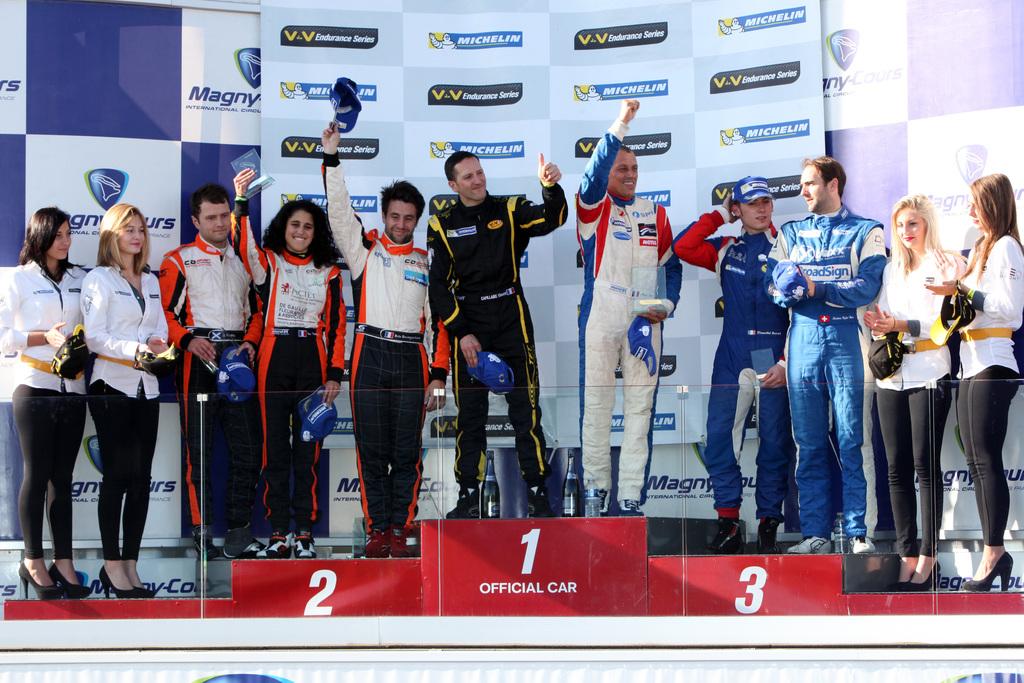What three numbers are shown?
Ensure brevity in your answer.  1 2 3. 